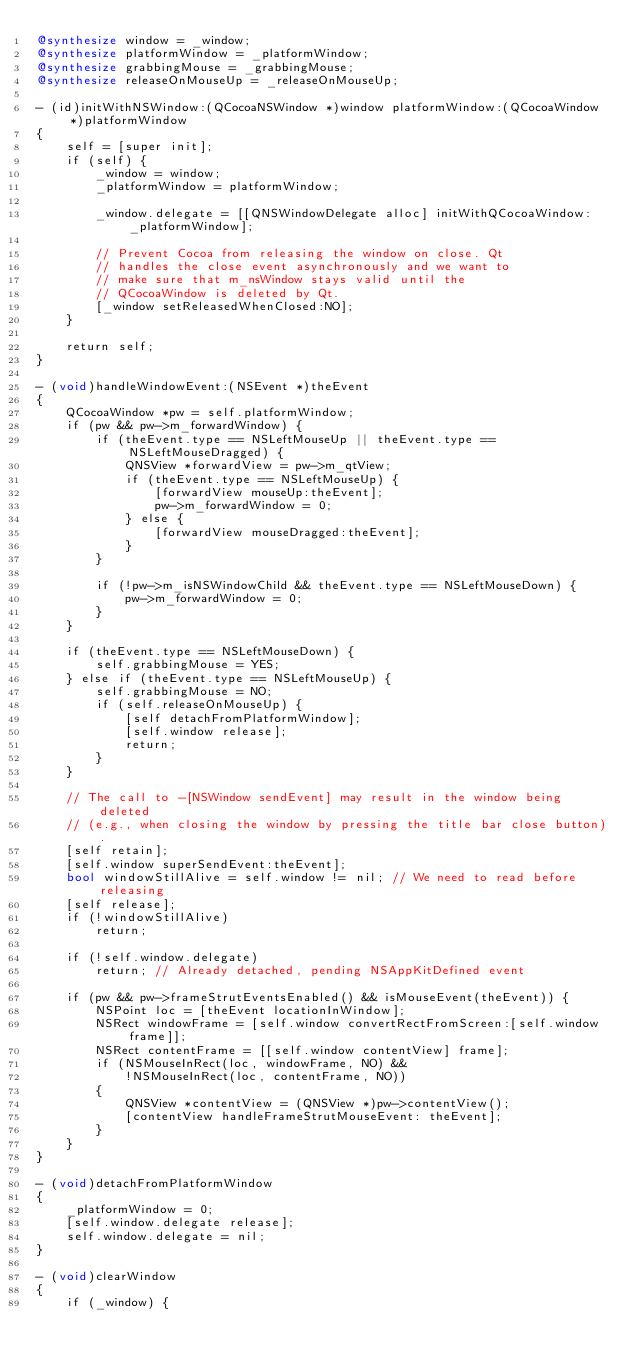Convert code to text. <code><loc_0><loc_0><loc_500><loc_500><_ObjectiveC_>@synthesize window = _window;
@synthesize platformWindow = _platformWindow;
@synthesize grabbingMouse = _grabbingMouse;
@synthesize releaseOnMouseUp = _releaseOnMouseUp;

- (id)initWithNSWindow:(QCocoaNSWindow *)window platformWindow:(QCocoaWindow *)platformWindow
{
    self = [super init];
    if (self) {
        _window = window;
        _platformWindow = platformWindow;

        _window.delegate = [[QNSWindowDelegate alloc] initWithQCocoaWindow:_platformWindow];

        // Prevent Cocoa from releasing the window on close. Qt
        // handles the close event asynchronously and we want to
        // make sure that m_nsWindow stays valid until the
        // QCocoaWindow is deleted by Qt.
        [_window setReleasedWhenClosed:NO];
    }

    return self;
}

- (void)handleWindowEvent:(NSEvent *)theEvent
{
    QCocoaWindow *pw = self.platformWindow;
    if (pw && pw->m_forwardWindow) {
        if (theEvent.type == NSLeftMouseUp || theEvent.type == NSLeftMouseDragged) {
            QNSView *forwardView = pw->m_qtView;
            if (theEvent.type == NSLeftMouseUp) {
                [forwardView mouseUp:theEvent];
                pw->m_forwardWindow = 0;
            } else {
                [forwardView mouseDragged:theEvent];
            }
        }

        if (!pw->m_isNSWindowChild && theEvent.type == NSLeftMouseDown) {
            pw->m_forwardWindow = 0;
        }
    }

    if (theEvent.type == NSLeftMouseDown) {
        self.grabbingMouse = YES;
    } else if (theEvent.type == NSLeftMouseUp) {
        self.grabbingMouse = NO;
        if (self.releaseOnMouseUp) {
            [self detachFromPlatformWindow];
            [self.window release];
            return;
        }
    }

    // The call to -[NSWindow sendEvent] may result in the window being deleted
    // (e.g., when closing the window by pressing the title bar close button).
    [self retain];
    [self.window superSendEvent:theEvent];
    bool windowStillAlive = self.window != nil; // We need to read before releasing
    [self release];
    if (!windowStillAlive)
        return;

    if (!self.window.delegate)
        return; // Already detached, pending NSAppKitDefined event

    if (pw && pw->frameStrutEventsEnabled() && isMouseEvent(theEvent)) {
        NSPoint loc = [theEvent locationInWindow];
        NSRect windowFrame = [self.window convertRectFromScreen:[self.window frame]];
        NSRect contentFrame = [[self.window contentView] frame];
        if (NSMouseInRect(loc, windowFrame, NO) &&
            !NSMouseInRect(loc, contentFrame, NO))
        {
            QNSView *contentView = (QNSView *)pw->contentView();
            [contentView handleFrameStrutMouseEvent: theEvent];
        }
    }
}

- (void)detachFromPlatformWindow
{
    _platformWindow = 0;
    [self.window.delegate release];
    self.window.delegate = nil;
}

- (void)clearWindow
{
    if (_window) {</code> 